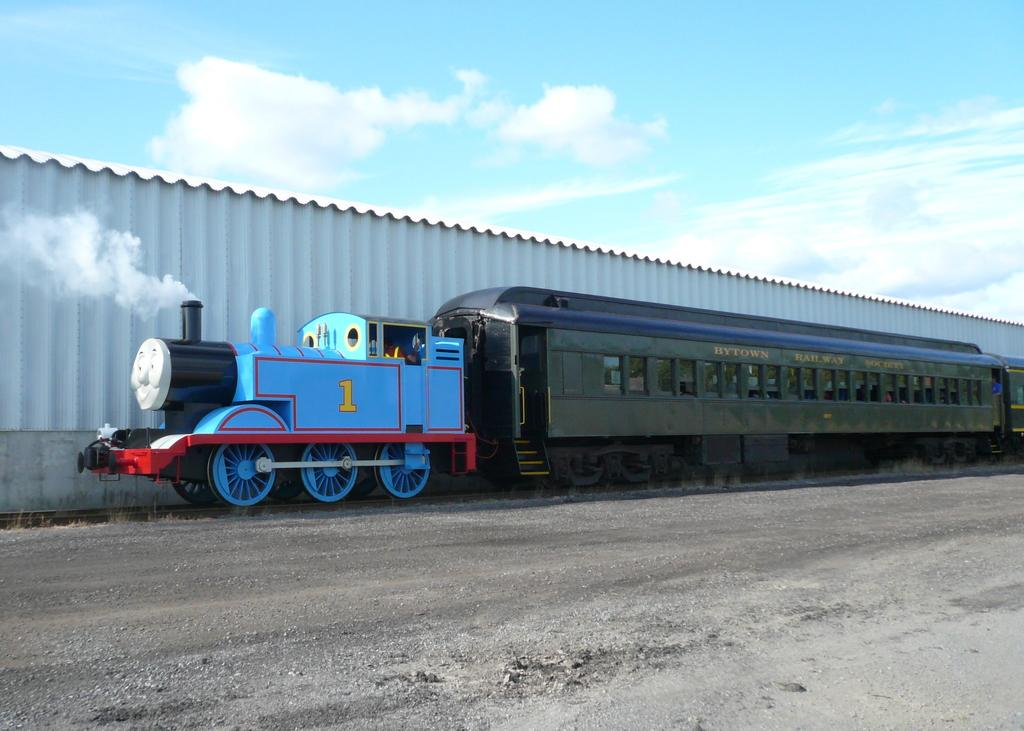What is in the foreground of the image? There is a road in the foreground of the image. What can be seen in the middle of the image? There is a train on the track in the middle of the image. What is the source of the smoke visible in the image? The smoke is likely coming from the train in the image. What type of wall is present in the image? There is a metal sheet wall in the image. What is visible at the top of the image? The sky is visible at the top of the image. What type of cloth is draped over the train in the image? There is no cloth draped over the train in the image; it is a train on a track with smoke visible. How does the leaf twist in the image? There is no leaf present in the image to twist. 